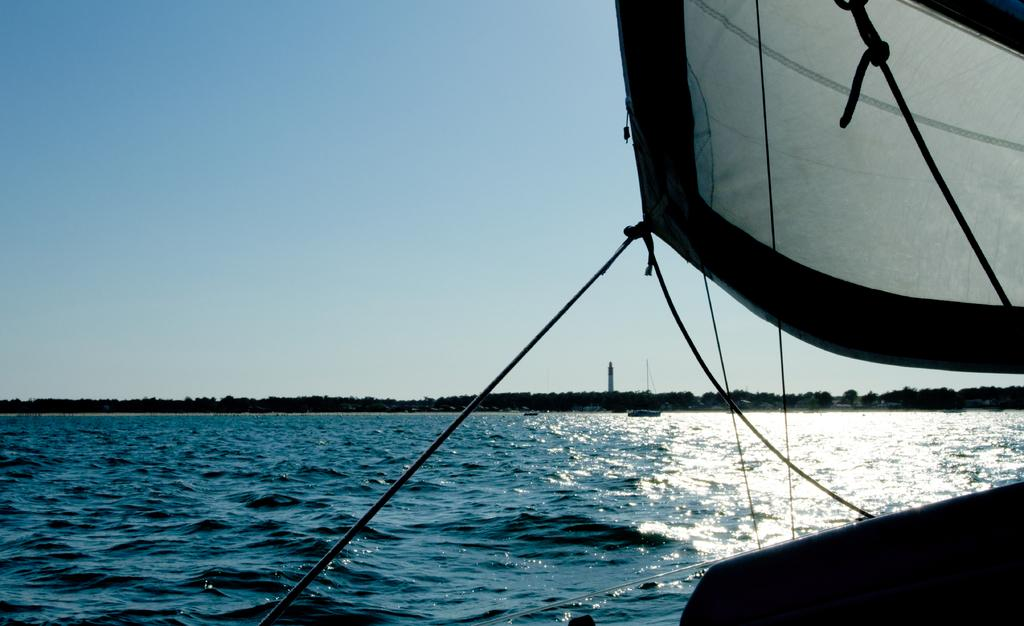What is the main subject of the image? The main subject of the image is a boat. Where is the boat located? The boat is on the water. What can be seen in the background of the image? There are towers, trees, and a beach in the background of the image. What is visible at the top of the image? The sky is visible at the top of the image. How many boats are in the image? There are two boats in the image. What type of orange is being used as an attraction in the image? There is no orange or attraction present in the image; it features a boat on the water with towers, trees, and a beach in the background. 